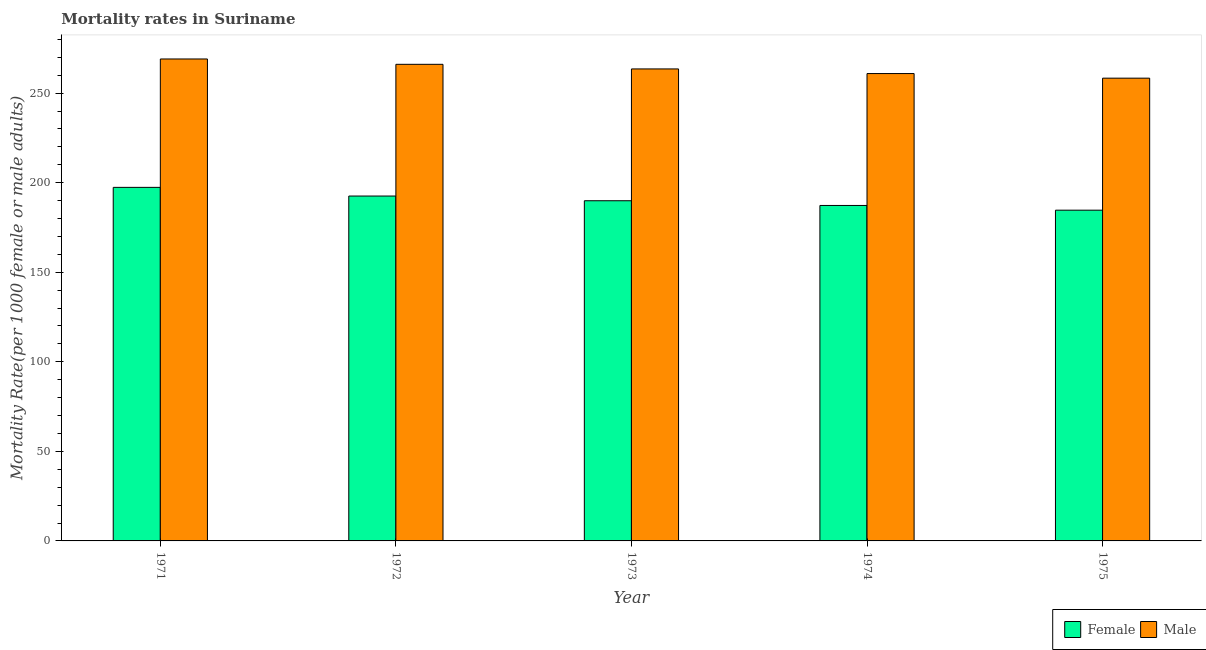How many groups of bars are there?
Your answer should be very brief. 5. Are the number of bars per tick equal to the number of legend labels?
Provide a succinct answer. Yes. Are the number of bars on each tick of the X-axis equal?
Your answer should be compact. Yes. How many bars are there on the 1st tick from the right?
Provide a short and direct response. 2. What is the female mortality rate in 1973?
Ensure brevity in your answer.  189.91. Across all years, what is the maximum male mortality rate?
Ensure brevity in your answer.  269.05. Across all years, what is the minimum female mortality rate?
Ensure brevity in your answer.  184.64. In which year was the female mortality rate maximum?
Offer a very short reply. 1971. In which year was the female mortality rate minimum?
Your answer should be compact. 1975. What is the total female mortality rate in the graph?
Provide a short and direct response. 951.73. What is the difference between the female mortality rate in 1972 and that in 1974?
Ensure brevity in your answer.  5.27. What is the difference between the male mortality rate in 1971 and the female mortality rate in 1975?
Your answer should be very brief. 10.71. What is the average female mortality rate per year?
Provide a short and direct response. 190.35. In the year 1971, what is the difference between the male mortality rate and female mortality rate?
Make the answer very short. 0. In how many years, is the male mortality rate greater than 100?
Offer a very short reply. 5. What is the ratio of the female mortality rate in 1974 to that in 1975?
Your answer should be very brief. 1.01. Is the female mortality rate in 1971 less than that in 1972?
Keep it short and to the point. No. Is the difference between the male mortality rate in 1971 and 1974 greater than the difference between the female mortality rate in 1971 and 1974?
Your answer should be very brief. No. What is the difference between the highest and the second highest male mortality rate?
Provide a short and direct response. 2.98. What is the difference between the highest and the lowest female mortality rate?
Give a very brief answer. 12.74. What does the 1st bar from the left in 1974 represents?
Your response must be concise. Female. What is the difference between two consecutive major ticks on the Y-axis?
Keep it short and to the point. 50. Are the values on the major ticks of Y-axis written in scientific E-notation?
Provide a short and direct response. No. Does the graph contain any zero values?
Make the answer very short. No. Does the graph contain grids?
Keep it short and to the point. No. Where does the legend appear in the graph?
Provide a succinct answer. Bottom right. How are the legend labels stacked?
Make the answer very short. Horizontal. What is the title of the graph?
Ensure brevity in your answer.  Mortality rates in Suriname. Does "Services" appear as one of the legend labels in the graph?
Your response must be concise. No. What is the label or title of the Y-axis?
Give a very brief answer. Mortality Rate(per 1000 female or male adults). What is the Mortality Rate(per 1000 female or male adults) of Female in 1971?
Make the answer very short. 197.38. What is the Mortality Rate(per 1000 female or male adults) of Male in 1971?
Your answer should be very brief. 269.05. What is the Mortality Rate(per 1000 female or male adults) of Female in 1972?
Your response must be concise. 192.54. What is the Mortality Rate(per 1000 female or male adults) in Male in 1972?
Keep it short and to the point. 266.07. What is the Mortality Rate(per 1000 female or male adults) of Female in 1973?
Give a very brief answer. 189.91. What is the Mortality Rate(per 1000 female or male adults) in Male in 1973?
Provide a succinct answer. 263.49. What is the Mortality Rate(per 1000 female or male adults) of Female in 1974?
Your answer should be very brief. 187.27. What is the Mortality Rate(per 1000 female or male adults) of Male in 1974?
Offer a very short reply. 260.92. What is the Mortality Rate(per 1000 female or male adults) in Female in 1975?
Ensure brevity in your answer.  184.64. What is the Mortality Rate(per 1000 female or male adults) of Male in 1975?
Provide a short and direct response. 258.34. Across all years, what is the maximum Mortality Rate(per 1000 female or male adults) of Female?
Make the answer very short. 197.38. Across all years, what is the maximum Mortality Rate(per 1000 female or male adults) in Male?
Offer a very short reply. 269.05. Across all years, what is the minimum Mortality Rate(per 1000 female or male adults) in Female?
Your answer should be compact. 184.64. Across all years, what is the minimum Mortality Rate(per 1000 female or male adults) in Male?
Provide a succinct answer. 258.34. What is the total Mortality Rate(per 1000 female or male adults) of Female in the graph?
Keep it short and to the point. 951.73. What is the total Mortality Rate(per 1000 female or male adults) in Male in the graph?
Your answer should be compact. 1317.87. What is the difference between the Mortality Rate(per 1000 female or male adults) in Female in 1971 and that in 1972?
Your answer should be very brief. 4.84. What is the difference between the Mortality Rate(per 1000 female or male adults) in Male in 1971 and that in 1972?
Provide a short and direct response. 2.98. What is the difference between the Mortality Rate(per 1000 female or male adults) in Female in 1971 and that in 1973?
Your answer should be compact. 7.47. What is the difference between the Mortality Rate(per 1000 female or male adults) in Male in 1971 and that in 1973?
Keep it short and to the point. 5.56. What is the difference between the Mortality Rate(per 1000 female or male adults) in Female in 1971 and that in 1974?
Your answer should be compact. 10.11. What is the difference between the Mortality Rate(per 1000 female or male adults) of Male in 1971 and that in 1974?
Provide a succinct answer. 8.14. What is the difference between the Mortality Rate(per 1000 female or male adults) of Female in 1971 and that in 1975?
Give a very brief answer. 12.74. What is the difference between the Mortality Rate(per 1000 female or male adults) of Male in 1971 and that in 1975?
Keep it short and to the point. 10.71. What is the difference between the Mortality Rate(per 1000 female or male adults) in Female in 1972 and that in 1973?
Offer a very short reply. 2.63. What is the difference between the Mortality Rate(per 1000 female or male adults) of Male in 1972 and that in 1973?
Your answer should be very brief. 2.58. What is the difference between the Mortality Rate(per 1000 female or male adults) of Female in 1972 and that in 1974?
Your answer should be very brief. 5.27. What is the difference between the Mortality Rate(per 1000 female or male adults) in Male in 1972 and that in 1974?
Your answer should be compact. 5.16. What is the difference between the Mortality Rate(per 1000 female or male adults) of Female in 1972 and that in 1975?
Ensure brevity in your answer.  7.9. What is the difference between the Mortality Rate(per 1000 female or male adults) of Male in 1972 and that in 1975?
Your answer should be very brief. 7.73. What is the difference between the Mortality Rate(per 1000 female or male adults) of Female in 1973 and that in 1974?
Offer a terse response. 2.63. What is the difference between the Mortality Rate(per 1000 female or male adults) in Male in 1973 and that in 1974?
Your answer should be very brief. 2.58. What is the difference between the Mortality Rate(per 1000 female or male adults) of Female in 1973 and that in 1975?
Give a very brief answer. 5.27. What is the difference between the Mortality Rate(per 1000 female or male adults) of Male in 1973 and that in 1975?
Keep it short and to the point. 5.16. What is the difference between the Mortality Rate(per 1000 female or male adults) in Female in 1974 and that in 1975?
Make the answer very short. 2.63. What is the difference between the Mortality Rate(per 1000 female or male adults) of Male in 1974 and that in 1975?
Make the answer very short. 2.58. What is the difference between the Mortality Rate(per 1000 female or male adults) in Female in 1971 and the Mortality Rate(per 1000 female or male adults) in Male in 1972?
Make the answer very short. -68.69. What is the difference between the Mortality Rate(per 1000 female or male adults) in Female in 1971 and the Mortality Rate(per 1000 female or male adults) in Male in 1973?
Your response must be concise. -66.11. What is the difference between the Mortality Rate(per 1000 female or male adults) in Female in 1971 and the Mortality Rate(per 1000 female or male adults) in Male in 1974?
Ensure brevity in your answer.  -63.54. What is the difference between the Mortality Rate(per 1000 female or male adults) of Female in 1971 and the Mortality Rate(per 1000 female or male adults) of Male in 1975?
Keep it short and to the point. -60.96. What is the difference between the Mortality Rate(per 1000 female or male adults) of Female in 1972 and the Mortality Rate(per 1000 female or male adults) of Male in 1973?
Offer a terse response. -70.95. What is the difference between the Mortality Rate(per 1000 female or male adults) of Female in 1972 and the Mortality Rate(per 1000 female or male adults) of Male in 1974?
Your response must be concise. -68.38. What is the difference between the Mortality Rate(per 1000 female or male adults) in Female in 1972 and the Mortality Rate(per 1000 female or male adults) in Male in 1975?
Provide a succinct answer. -65.8. What is the difference between the Mortality Rate(per 1000 female or male adults) of Female in 1973 and the Mortality Rate(per 1000 female or male adults) of Male in 1974?
Provide a succinct answer. -71.01. What is the difference between the Mortality Rate(per 1000 female or male adults) in Female in 1973 and the Mortality Rate(per 1000 female or male adults) in Male in 1975?
Provide a short and direct response. -68.43. What is the difference between the Mortality Rate(per 1000 female or male adults) in Female in 1974 and the Mortality Rate(per 1000 female or male adults) in Male in 1975?
Make the answer very short. -71.07. What is the average Mortality Rate(per 1000 female or male adults) in Female per year?
Offer a terse response. 190.35. What is the average Mortality Rate(per 1000 female or male adults) in Male per year?
Your answer should be very brief. 263.57. In the year 1971, what is the difference between the Mortality Rate(per 1000 female or male adults) in Female and Mortality Rate(per 1000 female or male adults) in Male?
Make the answer very short. -71.67. In the year 1972, what is the difference between the Mortality Rate(per 1000 female or male adults) of Female and Mortality Rate(per 1000 female or male adults) of Male?
Provide a succinct answer. -73.53. In the year 1973, what is the difference between the Mortality Rate(per 1000 female or male adults) in Female and Mortality Rate(per 1000 female or male adults) in Male?
Offer a very short reply. -73.59. In the year 1974, what is the difference between the Mortality Rate(per 1000 female or male adults) of Female and Mortality Rate(per 1000 female or male adults) of Male?
Your answer should be very brief. -73.64. In the year 1975, what is the difference between the Mortality Rate(per 1000 female or male adults) of Female and Mortality Rate(per 1000 female or male adults) of Male?
Your answer should be compact. -73.7. What is the ratio of the Mortality Rate(per 1000 female or male adults) in Female in 1971 to that in 1972?
Ensure brevity in your answer.  1.03. What is the ratio of the Mortality Rate(per 1000 female or male adults) in Male in 1971 to that in 1972?
Offer a very short reply. 1.01. What is the ratio of the Mortality Rate(per 1000 female or male adults) in Female in 1971 to that in 1973?
Your response must be concise. 1.04. What is the ratio of the Mortality Rate(per 1000 female or male adults) of Male in 1971 to that in 1973?
Provide a succinct answer. 1.02. What is the ratio of the Mortality Rate(per 1000 female or male adults) of Female in 1971 to that in 1974?
Ensure brevity in your answer.  1.05. What is the ratio of the Mortality Rate(per 1000 female or male adults) in Male in 1971 to that in 1974?
Your response must be concise. 1.03. What is the ratio of the Mortality Rate(per 1000 female or male adults) in Female in 1971 to that in 1975?
Your answer should be very brief. 1.07. What is the ratio of the Mortality Rate(per 1000 female or male adults) in Male in 1971 to that in 1975?
Provide a short and direct response. 1.04. What is the ratio of the Mortality Rate(per 1000 female or male adults) in Female in 1972 to that in 1973?
Offer a terse response. 1.01. What is the ratio of the Mortality Rate(per 1000 female or male adults) of Male in 1972 to that in 1973?
Keep it short and to the point. 1.01. What is the ratio of the Mortality Rate(per 1000 female or male adults) in Female in 1972 to that in 1974?
Offer a very short reply. 1.03. What is the ratio of the Mortality Rate(per 1000 female or male adults) of Male in 1972 to that in 1974?
Keep it short and to the point. 1.02. What is the ratio of the Mortality Rate(per 1000 female or male adults) of Female in 1972 to that in 1975?
Give a very brief answer. 1.04. What is the ratio of the Mortality Rate(per 1000 female or male adults) in Male in 1972 to that in 1975?
Your answer should be very brief. 1.03. What is the ratio of the Mortality Rate(per 1000 female or male adults) in Female in 1973 to that in 1974?
Keep it short and to the point. 1.01. What is the ratio of the Mortality Rate(per 1000 female or male adults) of Male in 1973 to that in 1974?
Offer a terse response. 1.01. What is the ratio of the Mortality Rate(per 1000 female or male adults) of Female in 1973 to that in 1975?
Keep it short and to the point. 1.03. What is the ratio of the Mortality Rate(per 1000 female or male adults) in Female in 1974 to that in 1975?
Give a very brief answer. 1.01. What is the difference between the highest and the second highest Mortality Rate(per 1000 female or male adults) in Female?
Ensure brevity in your answer.  4.84. What is the difference between the highest and the second highest Mortality Rate(per 1000 female or male adults) of Male?
Offer a very short reply. 2.98. What is the difference between the highest and the lowest Mortality Rate(per 1000 female or male adults) of Female?
Give a very brief answer. 12.74. What is the difference between the highest and the lowest Mortality Rate(per 1000 female or male adults) of Male?
Offer a terse response. 10.71. 